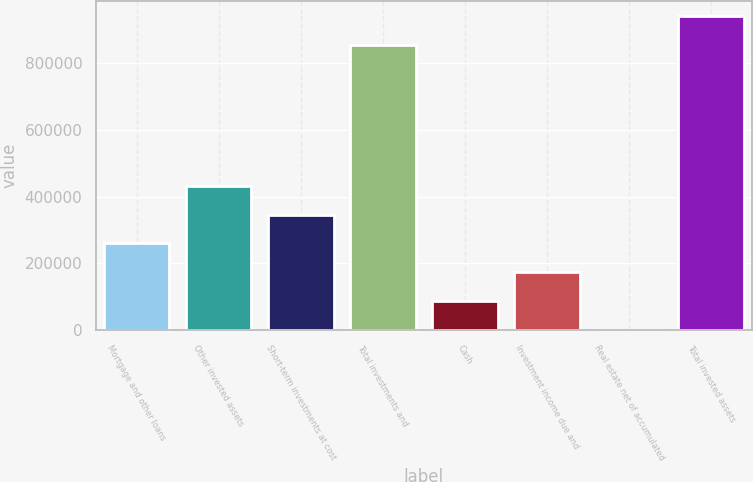<chart> <loc_0><loc_0><loc_500><loc_500><bar_chart><fcel>Mortgage and other loans<fcel>Other invested assets<fcel>Short-term investments at cost<fcel>Total investments and<fcel>Cash<fcel>Investment income due and<fcel>Real estate net of accumulated<fcel>Total invested assets<nl><fcel>259912<fcel>432078<fcel>345995<fcel>851961<fcel>87745.2<fcel>173828<fcel>1662<fcel>938044<nl></chart> 